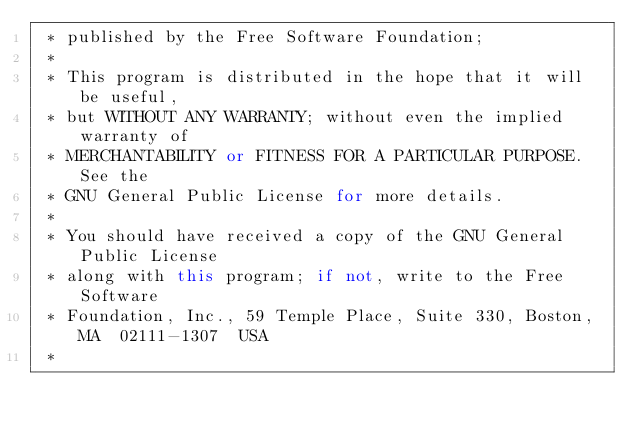Convert code to text. <code><loc_0><loc_0><loc_500><loc_500><_C++_> * published by the Free Software Foundation;
 *
 * This program is distributed in the hope that it will be useful,
 * but WITHOUT ANY WARRANTY; without even the implied warranty of
 * MERCHANTABILITY or FITNESS FOR A PARTICULAR PURPOSE.  See the
 * GNU General Public License for more details.
 *
 * You should have received a copy of the GNU General Public License
 * along with this program; if not, write to the Free Software
 * Foundation, Inc., 59 Temple Place, Suite 330, Boston, MA  02111-1307  USA
 *</code> 